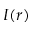Convert formula to latex. <formula><loc_0><loc_0><loc_500><loc_500>I ( r )</formula> 